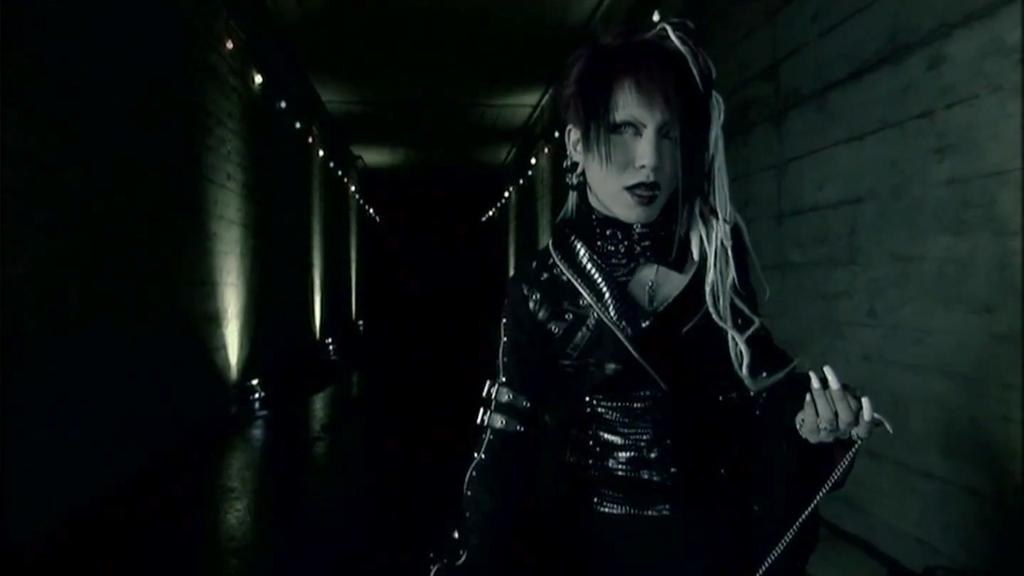Who is present in the image? There is a woman in the image. What is the woman doing in the image? The woman is standing. What can be seen in the background of the image? There are walls in the background of the image. What is attached to the walls in the image? There are lights on the walls. How would you describe the lighting in the image? The image appears to be in a dark setting. What type of camp can be seen in the background of the image? There is no camp present in the image; it features a woman standing in a setting with walls and lights. How many copies of the woman are visible in the image? There is only one woman visible in the image, so there are no copies. 